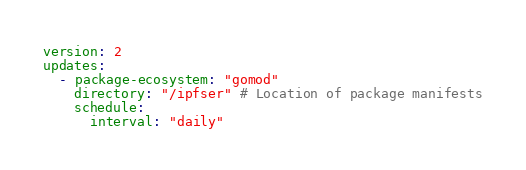<code> <loc_0><loc_0><loc_500><loc_500><_YAML_>
version: 2
updates:
  - package-ecosystem: "gomod"
    directory: "/ipfser" # Location of package manifests
    schedule:
      interval: "daily"
</code> 